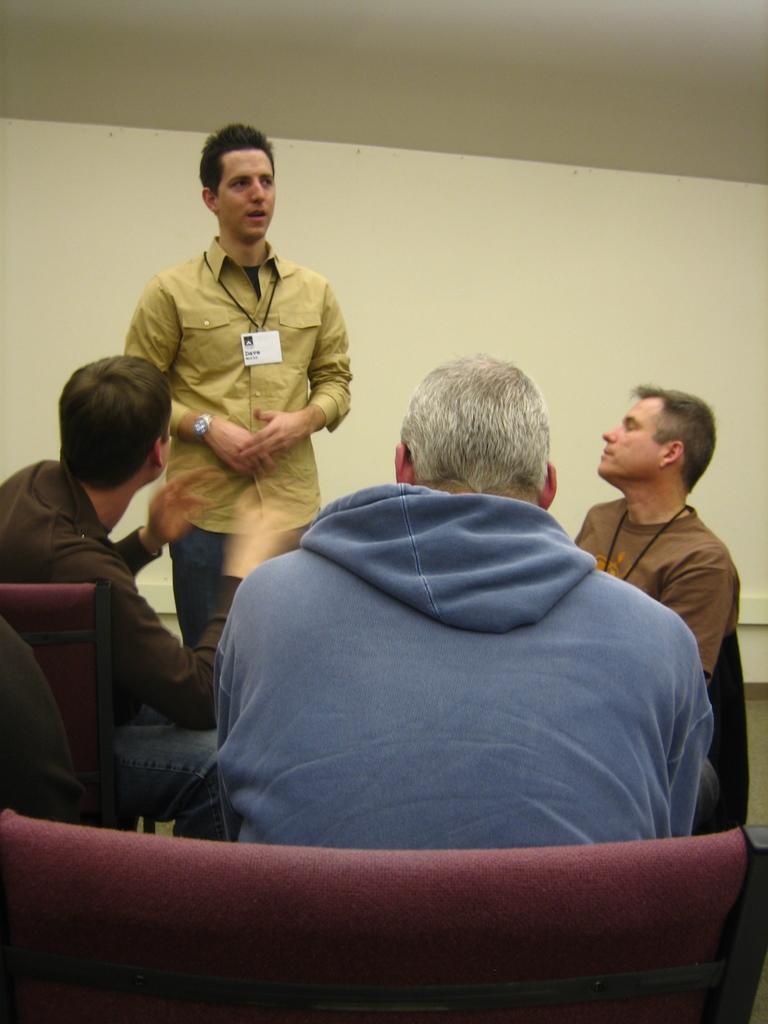Could you give a brief overview of what you see in this image? There are four members in the room. Three of them were sitting and one guy is standing and talking. In the background there is a wall. 